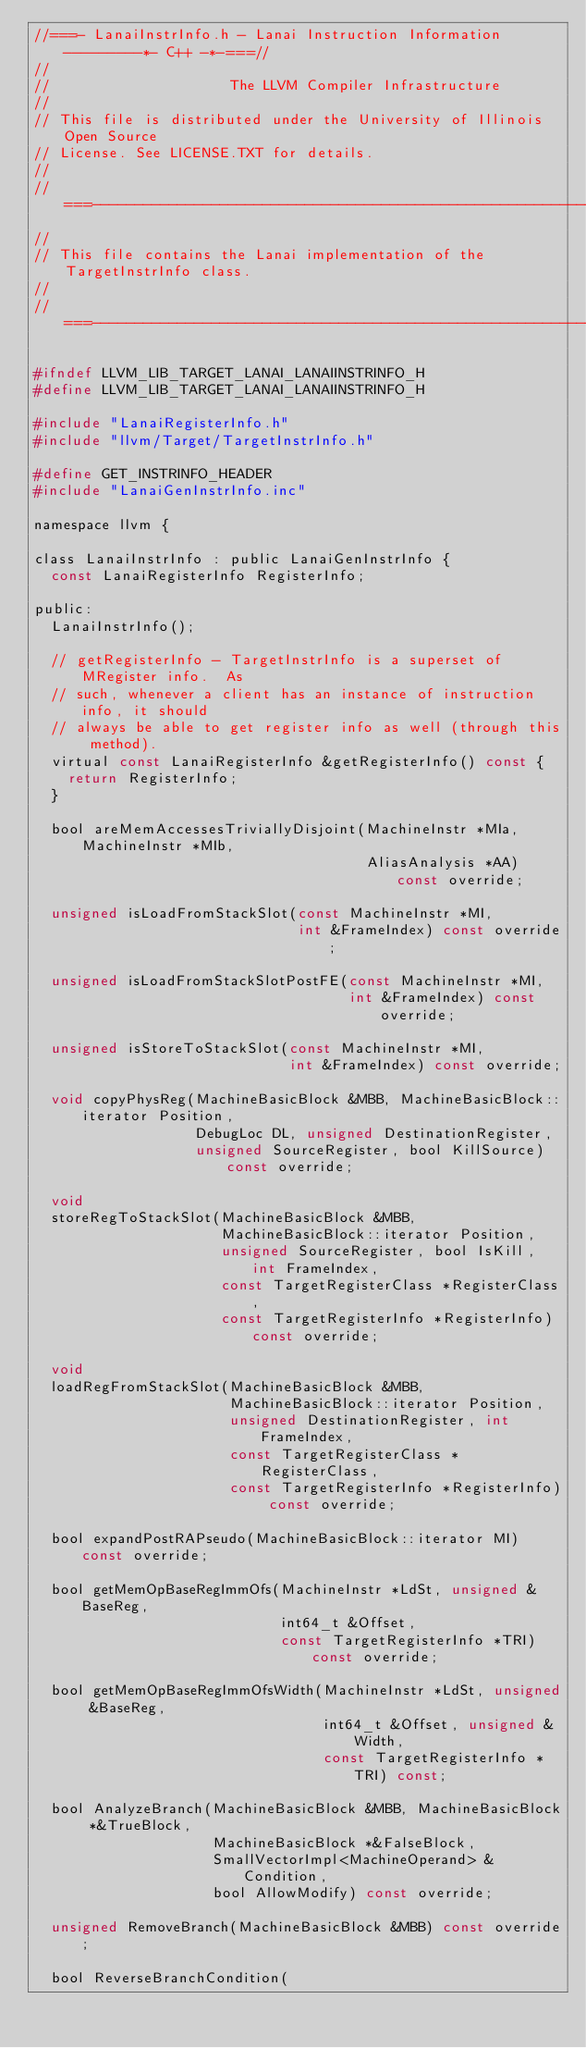Convert code to text. <code><loc_0><loc_0><loc_500><loc_500><_C_>//===- LanaiInstrInfo.h - Lanai Instruction Information ---------*- C++ -*-===//
//
//                     The LLVM Compiler Infrastructure
//
// This file is distributed under the University of Illinois Open Source
// License. See LICENSE.TXT for details.
//
//===----------------------------------------------------------------------===//
//
// This file contains the Lanai implementation of the TargetInstrInfo class.
//
//===----------------------------------------------------------------------===//

#ifndef LLVM_LIB_TARGET_LANAI_LANAIINSTRINFO_H
#define LLVM_LIB_TARGET_LANAI_LANAIINSTRINFO_H

#include "LanaiRegisterInfo.h"
#include "llvm/Target/TargetInstrInfo.h"

#define GET_INSTRINFO_HEADER
#include "LanaiGenInstrInfo.inc"

namespace llvm {

class LanaiInstrInfo : public LanaiGenInstrInfo {
  const LanaiRegisterInfo RegisterInfo;

public:
  LanaiInstrInfo();

  // getRegisterInfo - TargetInstrInfo is a superset of MRegister info.  As
  // such, whenever a client has an instance of instruction info, it should
  // always be able to get register info as well (through this method).
  virtual const LanaiRegisterInfo &getRegisterInfo() const {
    return RegisterInfo;
  }

  bool areMemAccessesTriviallyDisjoint(MachineInstr *MIa, MachineInstr *MIb,
                                       AliasAnalysis *AA) const override;

  unsigned isLoadFromStackSlot(const MachineInstr *MI,
                               int &FrameIndex) const override;

  unsigned isLoadFromStackSlotPostFE(const MachineInstr *MI,
                                     int &FrameIndex) const override;

  unsigned isStoreToStackSlot(const MachineInstr *MI,
                              int &FrameIndex) const override;

  void copyPhysReg(MachineBasicBlock &MBB, MachineBasicBlock::iterator Position,
                   DebugLoc DL, unsigned DestinationRegister,
                   unsigned SourceRegister, bool KillSource) const override;

  void
  storeRegToStackSlot(MachineBasicBlock &MBB,
                      MachineBasicBlock::iterator Position,
                      unsigned SourceRegister, bool IsKill, int FrameIndex,
                      const TargetRegisterClass *RegisterClass,
                      const TargetRegisterInfo *RegisterInfo) const override;

  void
  loadRegFromStackSlot(MachineBasicBlock &MBB,
                       MachineBasicBlock::iterator Position,
                       unsigned DestinationRegister, int FrameIndex,
                       const TargetRegisterClass *RegisterClass,
                       const TargetRegisterInfo *RegisterInfo) const override;

  bool expandPostRAPseudo(MachineBasicBlock::iterator MI) const override;

  bool getMemOpBaseRegImmOfs(MachineInstr *LdSt, unsigned &BaseReg,
                             int64_t &Offset,
                             const TargetRegisterInfo *TRI) const override;

  bool getMemOpBaseRegImmOfsWidth(MachineInstr *LdSt, unsigned &BaseReg,
                                  int64_t &Offset, unsigned &Width,
                                  const TargetRegisterInfo *TRI) const;

  bool AnalyzeBranch(MachineBasicBlock &MBB, MachineBasicBlock *&TrueBlock,
                     MachineBasicBlock *&FalseBlock,
                     SmallVectorImpl<MachineOperand> &Condition,
                     bool AllowModify) const override;

  unsigned RemoveBranch(MachineBasicBlock &MBB) const override;

  bool ReverseBranchCondition(</code> 